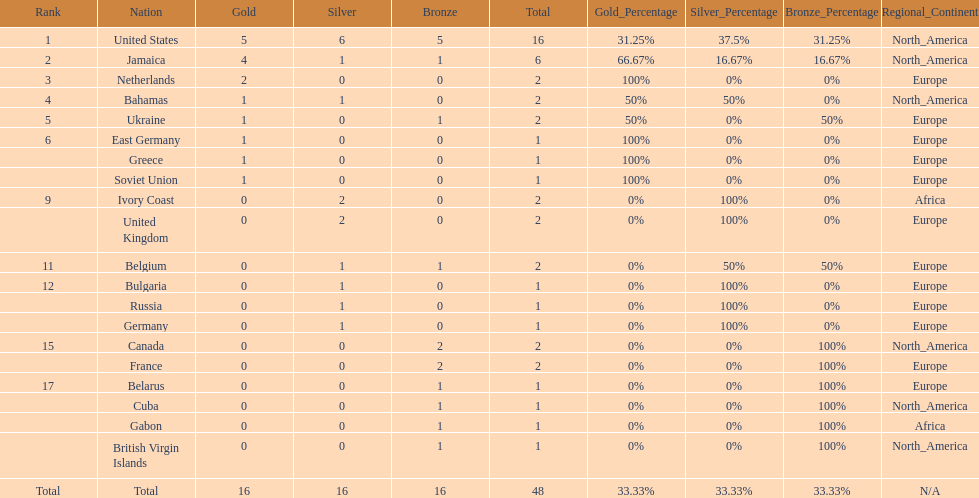What number of nations received 1 medal? 10. 